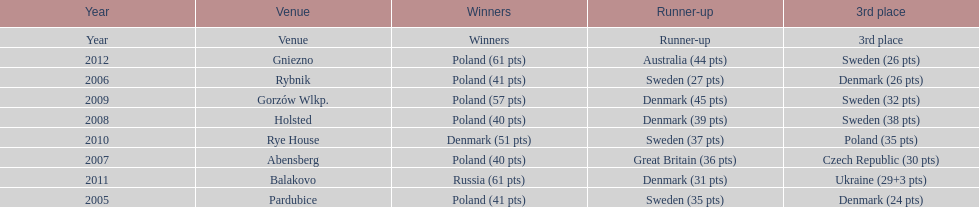After 2008 how many points total were scored by winners? 230. Could you parse the entire table as a dict? {'header': ['Year', 'Venue', 'Winners', 'Runner-up', '3rd place'], 'rows': [['Year', 'Venue', 'Winners', 'Runner-up', '3rd place'], ['2012', 'Gniezno', 'Poland (61 pts)', 'Australia (44 pts)', 'Sweden (26 pts)'], ['2006', 'Rybnik', 'Poland (41 pts)', 'Sweden (27 pts)', 'Denmark (26 pts)'], ['2009', 'Gorzów Wlkp.', 'Poland (57 pts)', 'Denmark (45 pts)', 'Sweden (32 pts)'], ['2008', 'Holsted', 'Poland (40 pts)', 'Denmark (39 pts)', 'Sweden (38 pts)'], ['2010', 'Rye House', 'Denmark (51 pts)', 'Sweden (37 pts)', 'Poland (35 pts)'], ['2007', 'Abensberg', 'Poland (40 pts)', 'Great Britain (36 pts)', 'Czech Republic (30 pts)'], ['2011', 'Balakovo', 'Russia (61 pts)', 'Denmark (31 pts)', 'Ukraine (29+3 pts)'], ['2005', 'Pardubice', 'Poland (41 pts)', 'Sweden (35 pts)', 'Denmark (24 pts)']]} 